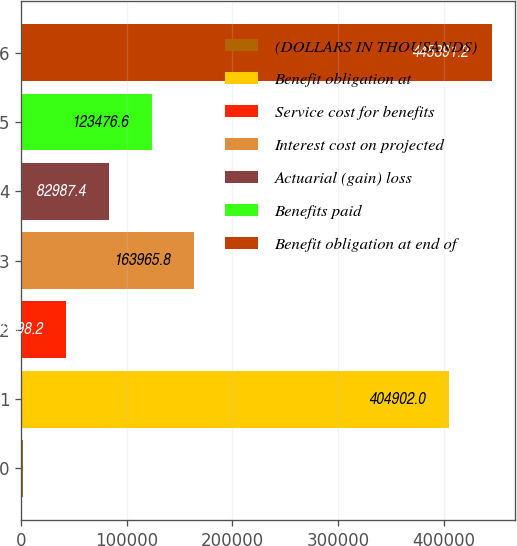Convert chart to OTSL. <chart><loc_0><loc_0><loc_500><loc_500><bar_chart><fcel>(DOLLARS IN THOUSANDS)<fcel>Benefit obligation at<fcel>Service cost for benefits<fcel>Interest cost on projected<fcel>Actuarial (gain) loss<fcel>Benefits paid<fcel>Benefit obligation at end of<nl><fcel>2009<fcel>404902<fcel>42498.2<fcel>163966<fcel>82987.4<fcel>123477<fcel>445391<nl></chart> 